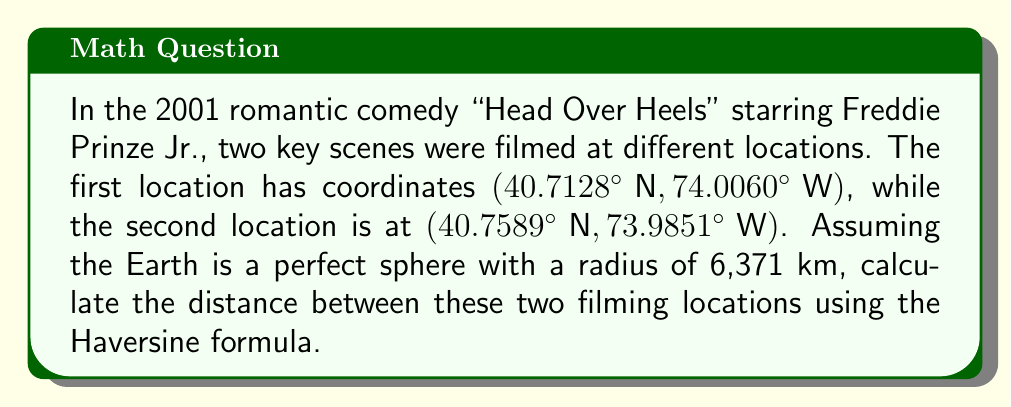Can you solve this math problem? To solve this problem, we'll use the Haversine formula, which calculates the great-circle distance between two points on a sphere given their latitudes and longitudes. Let's break it down step-by-step:

1. Convert the coordinates from degrees to radians:
   $\phi_1 = 40.7128° \times \frac{\pi}{180} = 0.7103$ rad
   $\lambda_1 = -74.0060° \times \frac{\pi}{180} = -1.2917$ rad
   $\phi_2 = 40.7589° \times \frac{\pi}{180} = 0.7112$ rad
   $\lambda_2 = -73.9851° \times \frac{\pi}{180} = -1.2914$ rad

2. Calculate the differences in latitude and longitude:
   $\Delta\phi = \phi_2 - \phi_1 = 0.7112 - 0.7103 = 0.0009$ rad
   $\Delta\lambda = \lambda_2 - \lambda_1 = -1.2914 - (-1.2917) = 0.0003$ rad

3. Apply the Haversine formula:
   $$a = \sin^2(\frac{\Delta\phi}{2}) + \cos(\phi_1) \cos(\phi_2) \sin^2(\frac{\Delta\lambda}{2})$$
   $$c = 2 \arctan2(\sqrt{a}, \sqrt{1-a})$$
   $$d = R \times c$$

   where $R$ is the Earth's radius (6,371 km)

4. Calculate $a$:
   $a = \sin^2(0.00045) + \cos(0.7103) \cos(0.7112) \sin^2(0.00015)$
   $a = 2.025 \times 10^{-7} + 0.7609 \times 0.7602 \times 2.25 \times 10^{-8}$
   $a = 2.038 \times 10^{-7}$

5. Calculate $c$:
   $c = 2 \arctan2(\sqrt{2.038 \times 10^{-7}}, \sqrt{1 - 2.038 \times 10^{-7}})$
   $c = 0.0009016$

6. Calculate the distance $d$:
   $d = 6371 \times 0.0009016 = 5.744$ km

Therefore, the distance between the two filming locations is approximately 5.744 km.
Answer: 5.744 km 